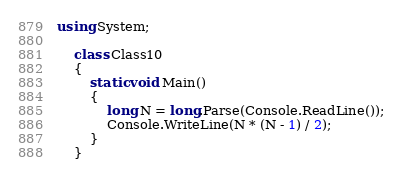<code> <loc_0><loc_0><loc_500><loc_500><_C#_>using System;

    class Class10
    {
        static void Main()
        {
            long N = long.Parse(Console.ReadLine());
            Console.WriteLine(N * (N - 1) / 2);
        }
    }</code> 